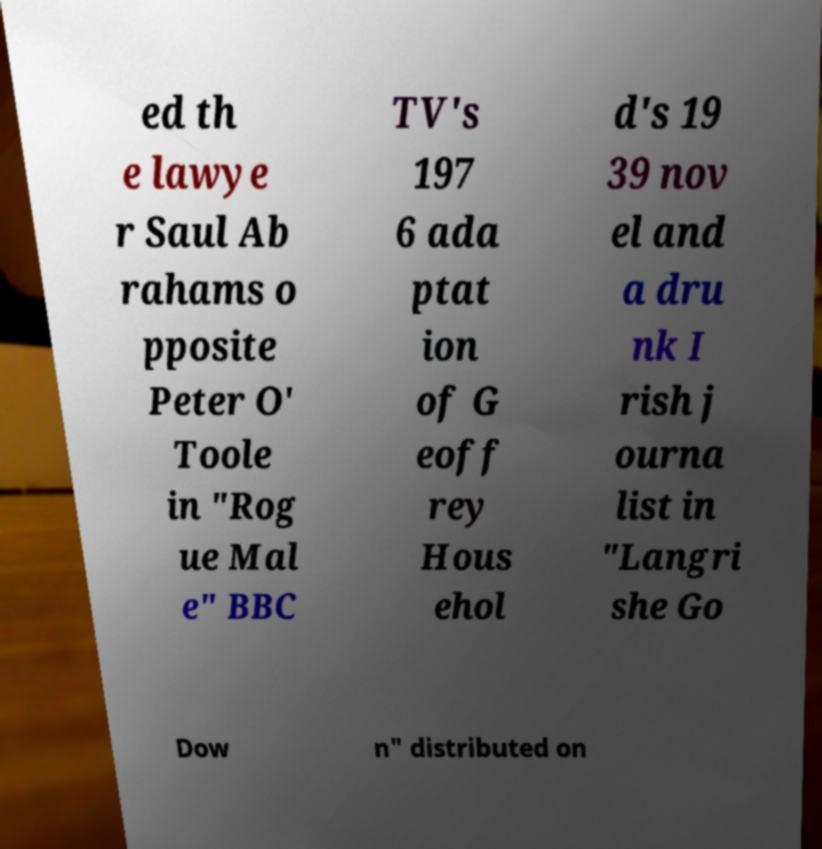There's text embedded in this image that I need extracted. Can you transcribe it verbatim? ed th e lawye r Saul Ab rahams o pposite Peter O' Toole in "Rog ue Mal e" BBC TV's 197 6 ada ptat ion of G eoff rey Hous ehol d's 19 39 nov el and a dru nk I rish j ourna list in "Langri she Go Dow n" distributed on 